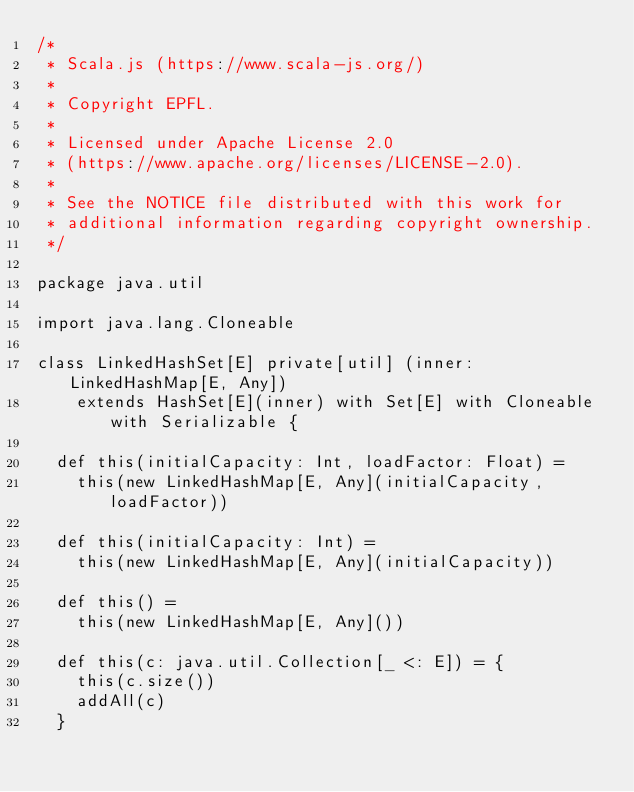<code> <loc_0><loc_0><loc_500><loc_500><_Scala_>/*
 * Scala.js (https://www.scala-js.org/)
 *
 * Copyright EPFL.
 *
 * Licensed under Apache License 2.0
 * (https://www.apache.org/licenses/LICENSE-2.0).
 *
 * See the NOTICE file distributed with this work for
 * additional information regarding copyright ownership.
 */

package java.util

import java.lang.Cloneable

class LinkedHashSet[E] private[util] (inner: LinkedHashMap[E, Any])
    extends HashSet[E](inner) with Set[E] with Cloneable with Serializable {

  def this(initialCapacity: Int, loadFactor: Float) =
    this(new LinkedHashMap[E, Any](initialCapacity, loadFactor))

  def this(initialCapacity: Int) =
    this(new LinkedHashMap[E, Any](initialCapacity))

  def this() =
    this(new LinkedHashMap[E, Any]())

  def this(c: java.util.Collection[_ <: E]) = {
    this(c.size())
    addAll(c)
  }
</code> 